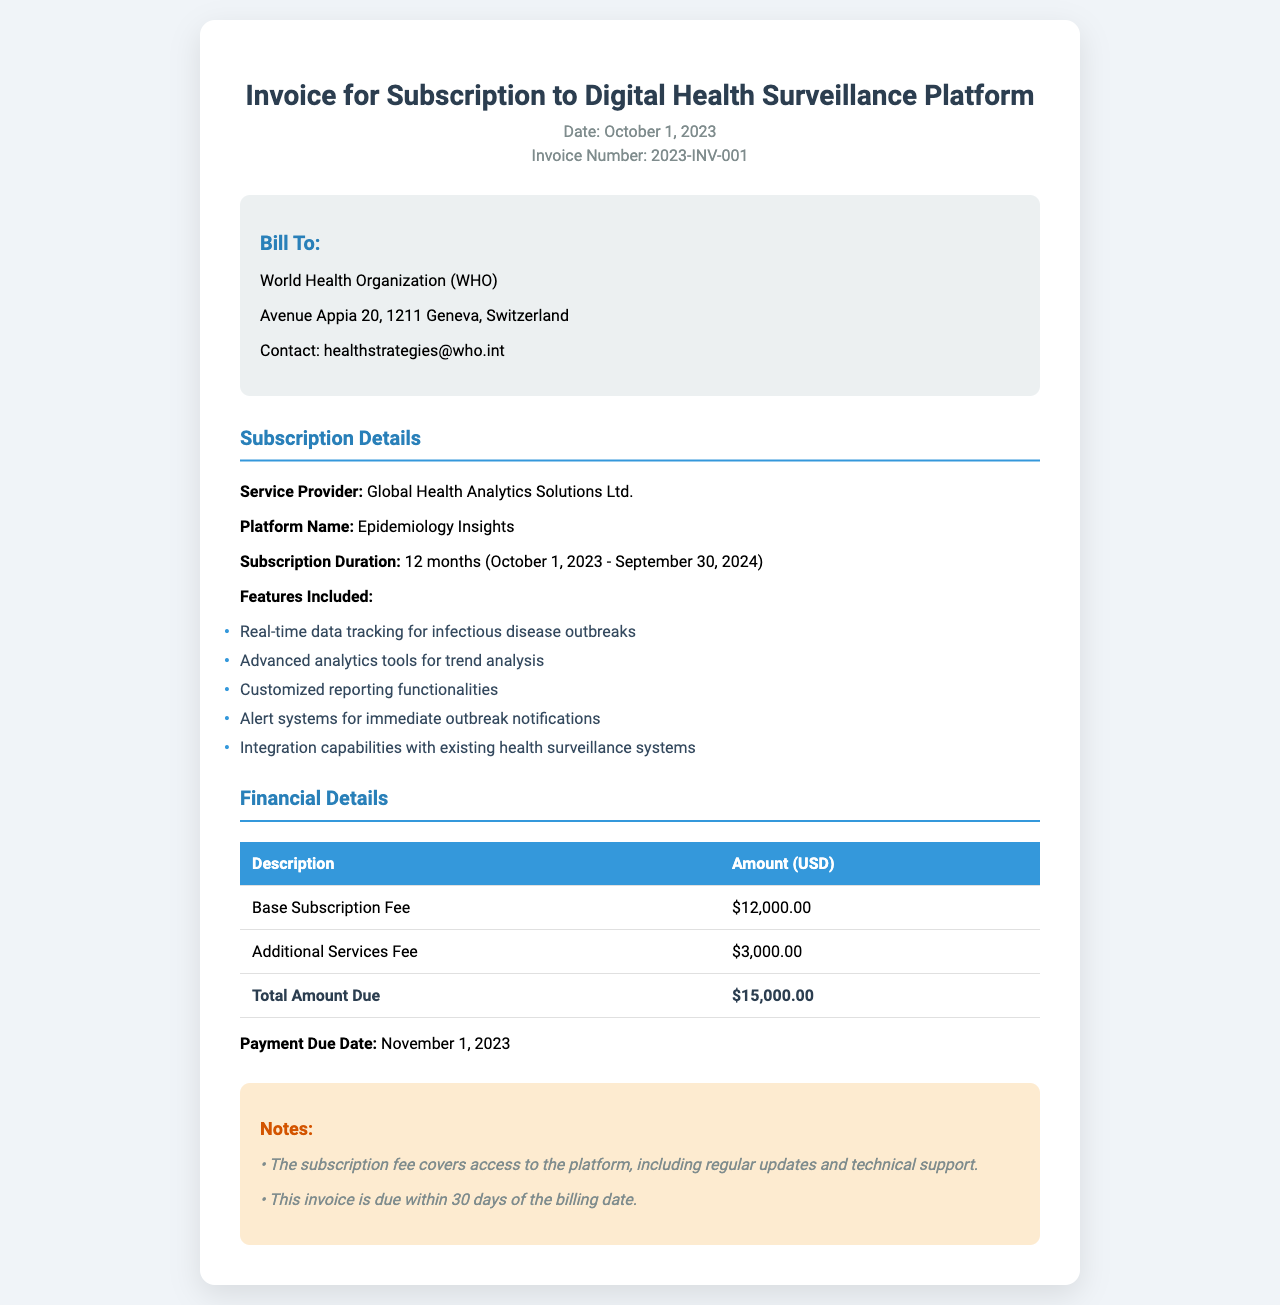What is the invoice date? The invoice date is clearly stated in the header section of the document as October 1, 2023.
Answer: October 1, 2023 Who is the service provider? The service provider is mentioned in the subscription details section of the document as Global Health Analytics Solutions Ltd.
Answer: Global Health Analytics Solutions Ltd What is the total amount due? The total amount due is the final figure presented in the financial details section, specifically identified as Total Amount Due.
Answer: $15,000.00 What is the subscription duration? The subscription duration is found in the subscription details section, indicating the time frame for the service.
Answer: 12 months (October 1, 2023 - September 30, 2024) When is the payment due date? The payment due date is noted in the financial details section as the deadline for payment.
Answer: November 1, 2023 What features are included in the subscription? The features included in the subscription are listed in the subscription details section of the document.
Answer: Real-time data tracking for infectious disease outbreaks; Advanced analytics tools for trend analysis; Customized reporting functionalities; Alert systems for immediate outbreak notifications; Integration capabilities with existing health surveillance systems What is the additional services fee? The additional services fee is specified in the financial details section of the invoice under the relevant line item.
Answer: $3,000.00 What type of document is this? The document is identified in the title and header section, describing it as an invoice.
Answer: Invoice 